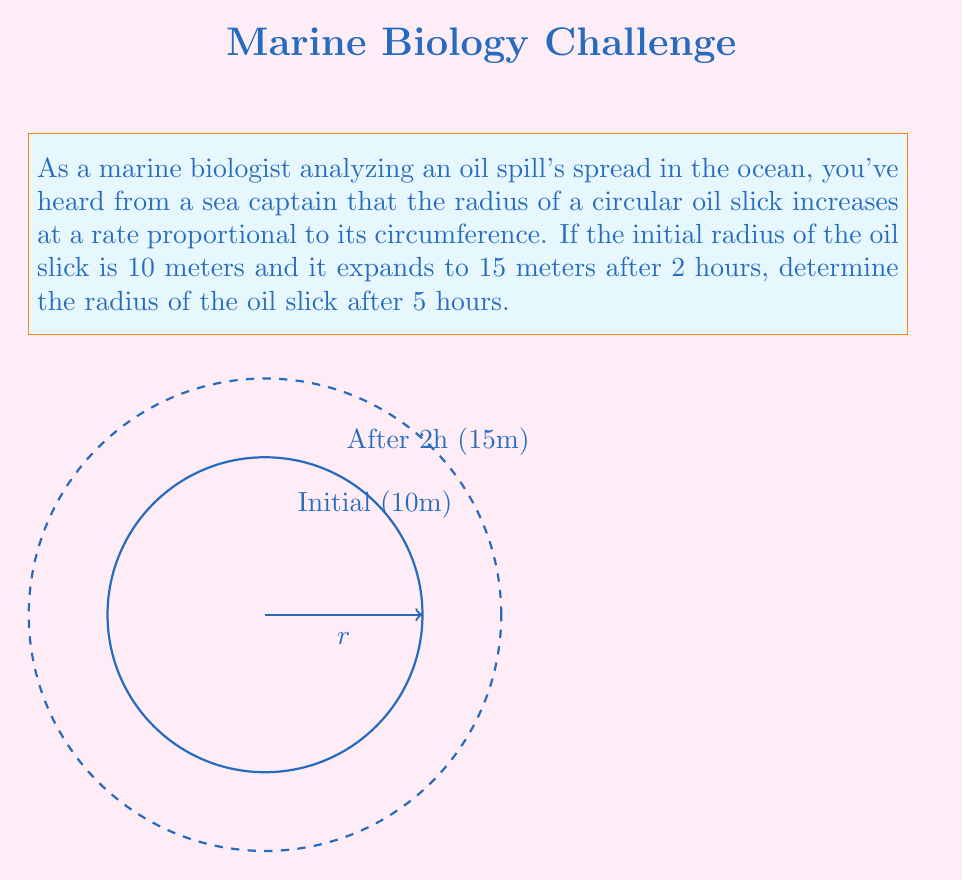Teach me how to tackle this problem. Let's approach this step-by-step:

1) Let $r$ be the radius of the oil slick at time $t$. The rate of change of the radius is proportional to the circumference:

   $$\frac{dr}{dt} = k \cdot 2\pi r$$

   where $k$ is the proportionality constant.

2) This is a separable differential equation. Rearranging:

   $$\frac{dr}{r} = 2\pi k \cdot dt$$

3) Integrating both sides:

   $$\int \frac{dr}{r} = \int 2\pi k \cdot dt$$
   $$\ln|r| = 2\pi kt + C$$

4) Solving for $r$:

   $$r = e^{2\pi kt + C} = Ae^{2\pi kt}$$

   where $A = e^C$ is a constant.

5) Using the initial condition: at $t=0$, $r=10$:

   $$10 = Ae^{2\pi k \cdot 0} = A$$

6) So our solution is:

   $$r = 10e^{2\pi kt}$$

7) Now, we use the condition that at $t=2$, $r=15$:

   $$15 = 10e^{2\pi k \cdot 2}$$
   $$\frac{3}{2} = e^{4\pi k}$$
   $$\ln(\frac{3}{2}) = 4\pi k$$
   $$k = \frac{\ln(\frac{3}{2})}{4\pi}$$

8) Substituting this back into our solution:

   $$r = 10e^{2\pi \cdot \frac{\ln(\frac{3}{2})}{4\pi} \cdot t} = 10e^{\frac{\ln(\frac{3}{2})}{2} \cdot t}$$

9) Now, we can find the radius at $t=5$:

   $$r = 10e^{\frac{\ln(\frac{3}{2})}{2} \cdot 5} \approx 22.5$$

Thus, after 5 hours, the radius of the oil slick will be approximately 22.5 meters.
Answer: $22.5$ meters 